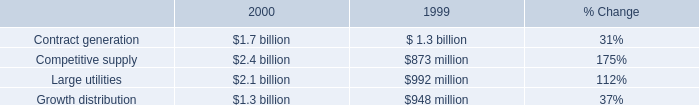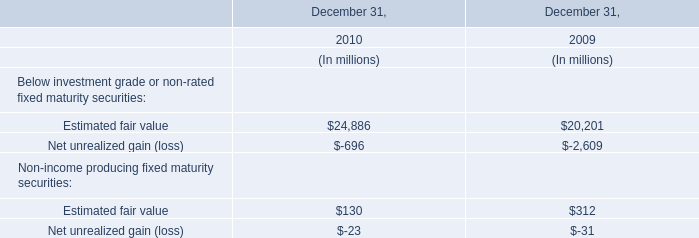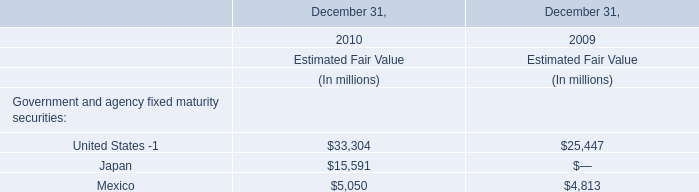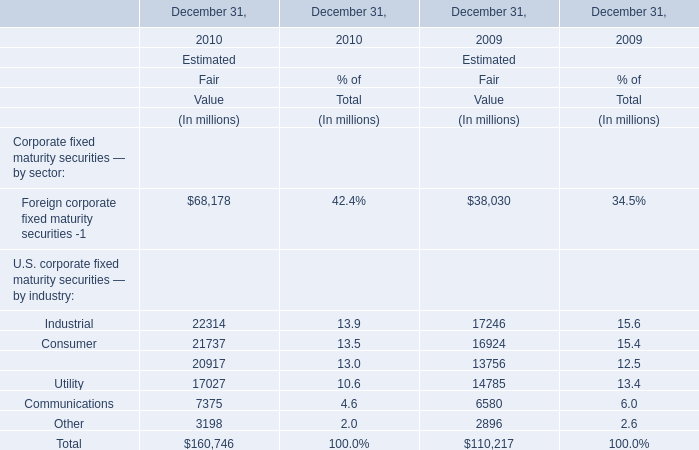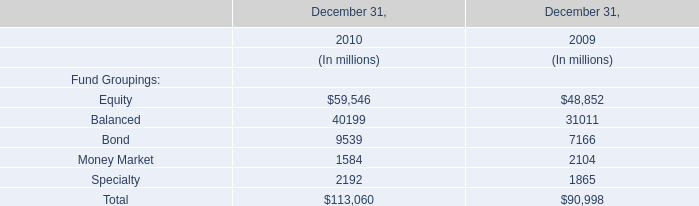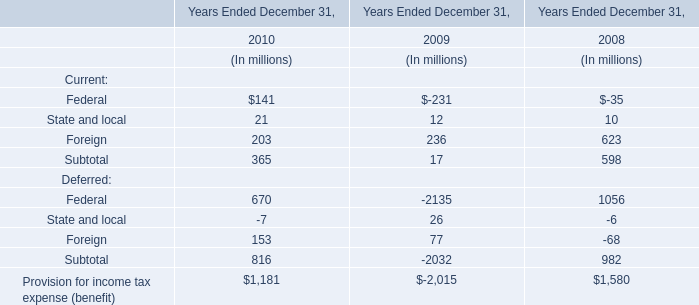Which year is Foreign corporate fixed maturity securities -1 the highest? 
Answer: 2010. 